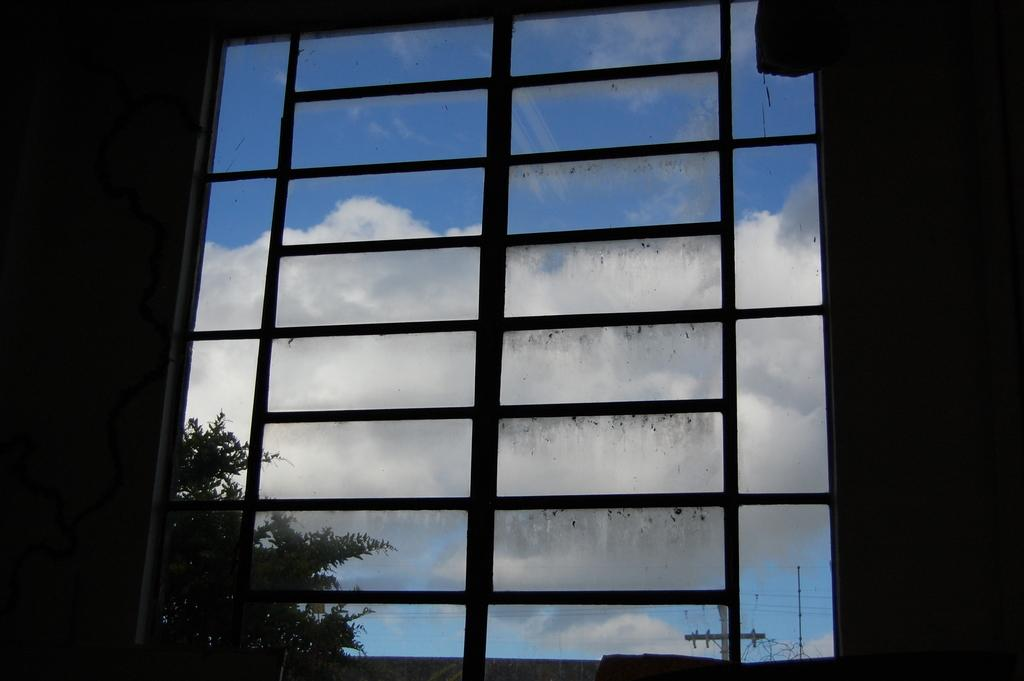What is present in the image that allows for a view of the outside? There is a window in the image that provides a view of the outside. What can be seen outside the window? Trees and poles are visible outside the window. What is visible at the top of the image? The sky is visible at the top of the image. What can be observed in the sky? Clouds are present in the sky. What type of honey can be seen dripping from the window in the image? There is no honey present in the image, and therefore no such activity can be observed. 